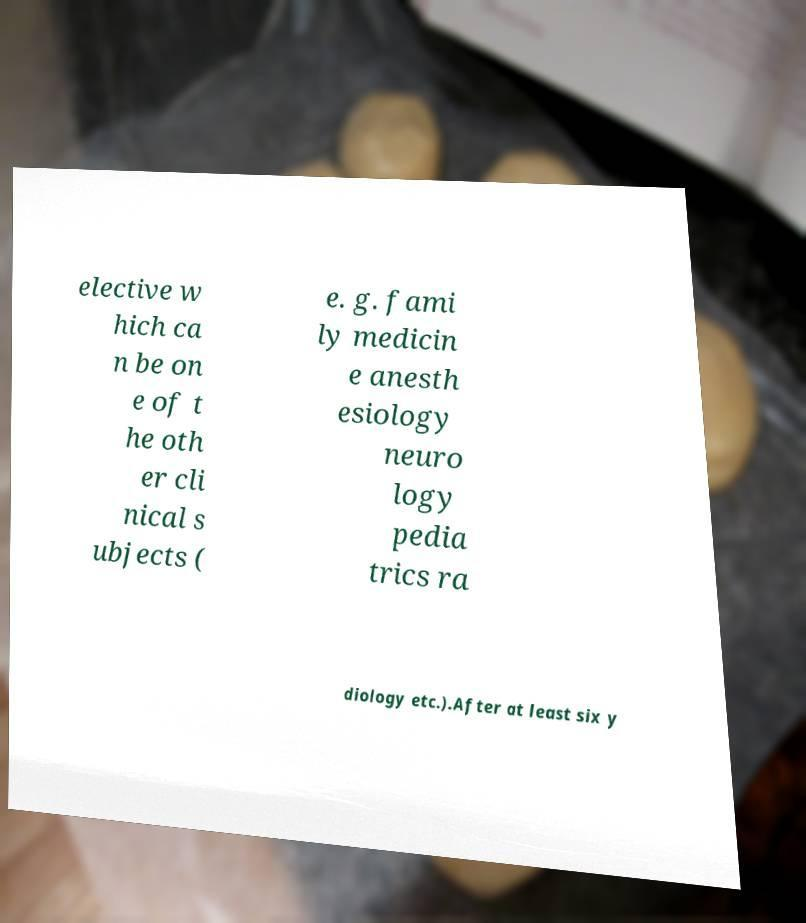Could you assist in decoding the text presented in this image and type it out clearly? elective w hich ca n be on e of t he oth er cli nical s ubjects ( e. g. fami ly medicin e anesth esiology neuro logy pedia trics ra diology etc.).After at least six y 